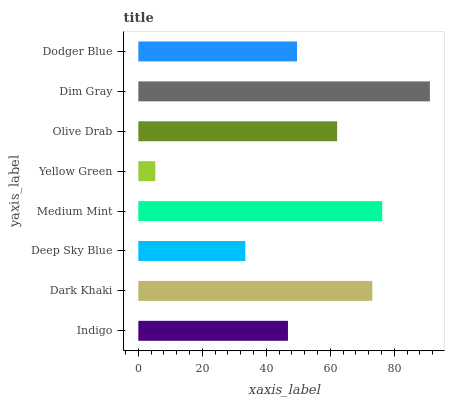Is Yellow Green the minimum?
Answer yes or no. Yes. Is Dim Gray the maximum?
Answer yes or no. Yes. Is Dark Khaki the minimum?
Answer yes or no. No. Is Dark Khaki the maximum?
Answer yes or no. No. Is Dark Khaki greater than Indigo?
Answer yes or no. Yes. Is Indigo less than Dark Khaki?
Answer yes or no. Yes. Is Indigo greater than Dark Khaki?
Answer yes or no. No. Is Dark Khaki less than Indigo?
Answer yes or no. No. Is Olive Drab the high median?
Answer yes or no. Yes. Is Dodger Blue the low median?
Answer yes or no. Yes. Is Dodger Blue the high median?
Answer yes or no. No. Is Medium Mint the low median?
Answer yes or no. No. 